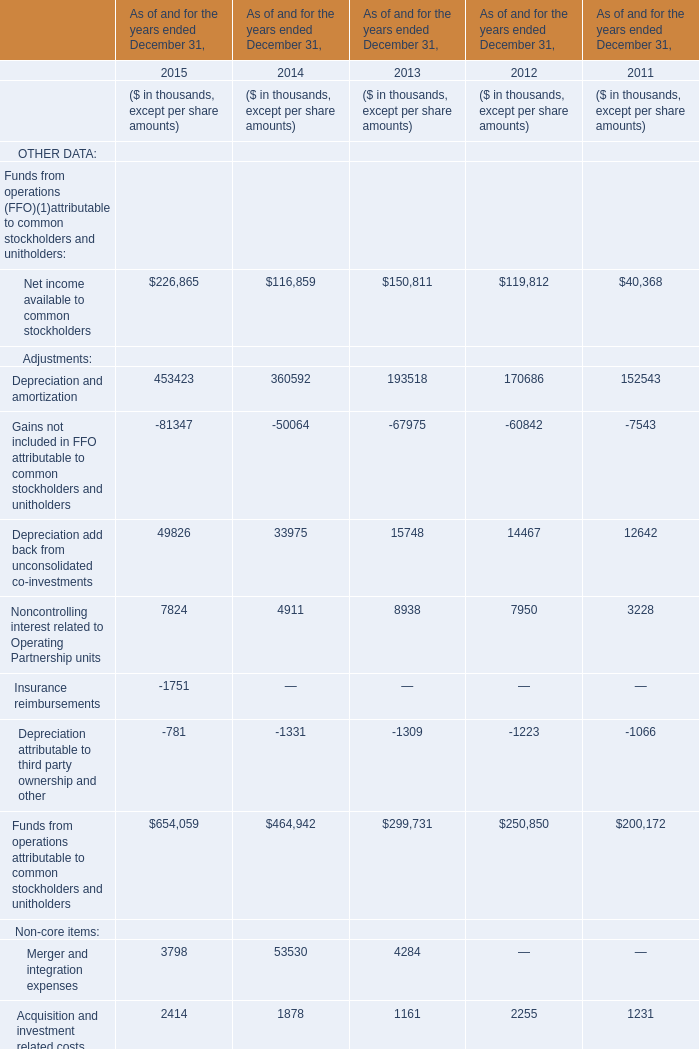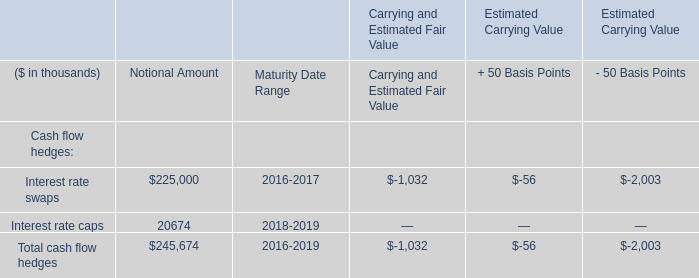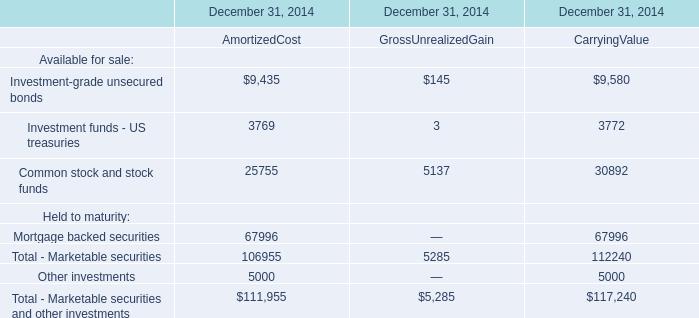In the year with lowest amount of Acquisition and investment related costs, what's the increasing rate of Depreciation and amortization? 
Computations: ((193518 - 170686) / 170686)
Answer: 0.13377. 